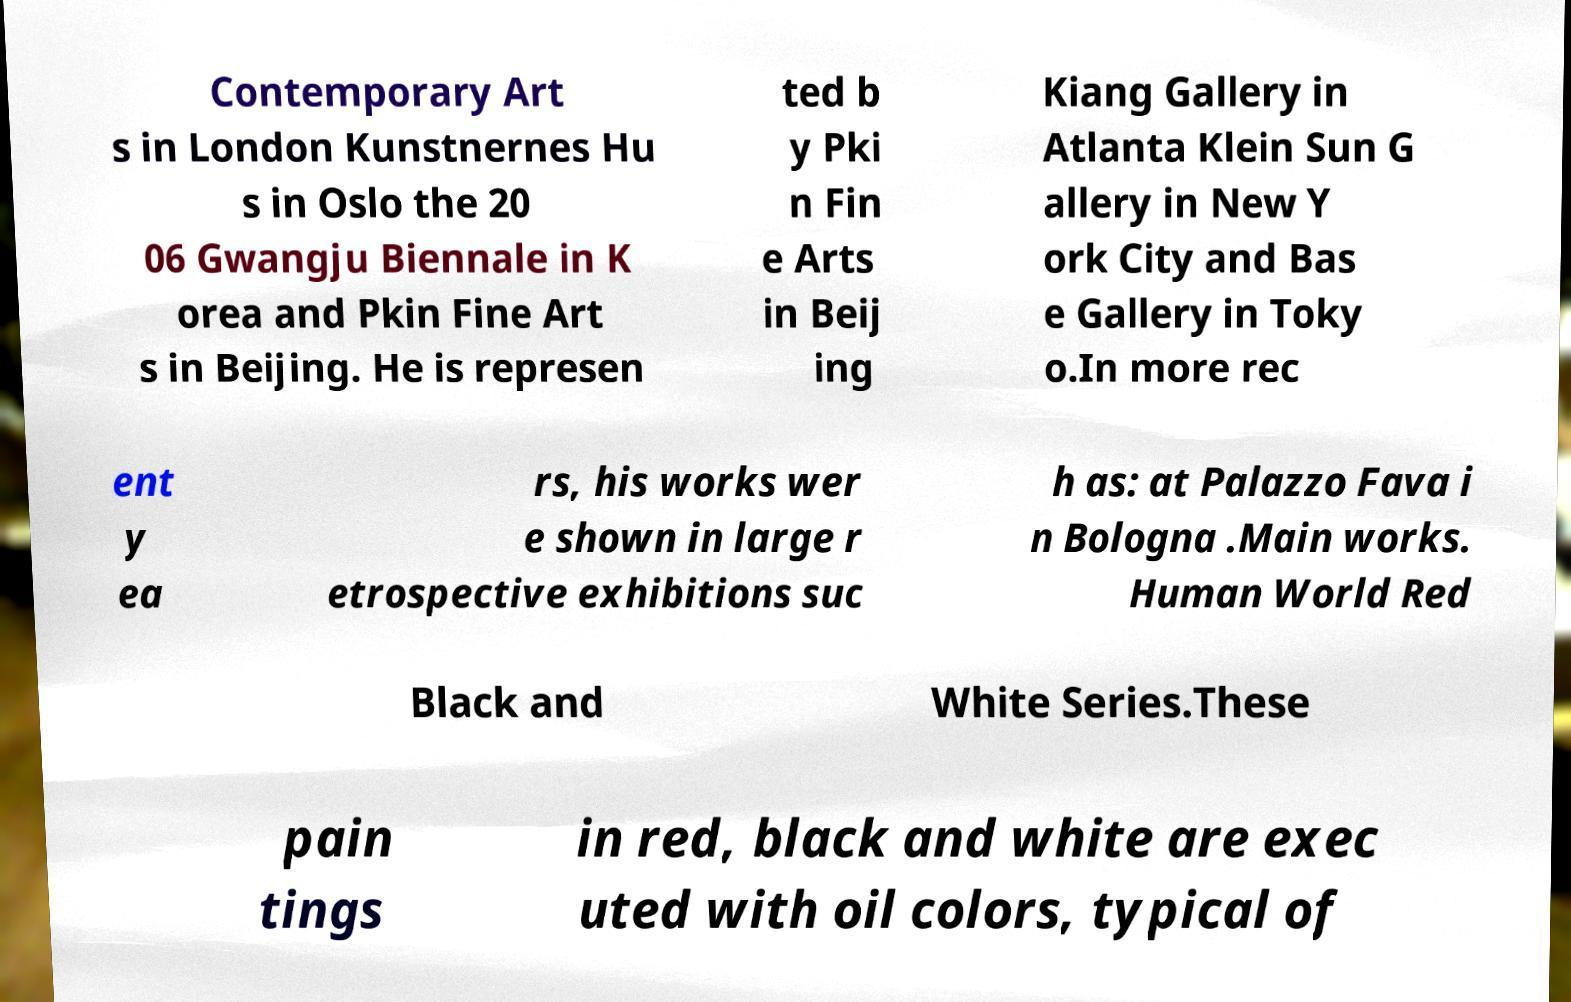What messages or text are displayed in this image? I need them in a readable, typed format. Contemporary Art s in London Kunstnernes Hu s in Oslo the 20 06 Gwangju Biennale in K orea and Pkin Fine Art s in Beijing. He is represen ted b y Pki n Fin e Arts in Beij ing Kiang Gallery in Atlanta Klein Sun G allery in New Y ork City and Bas e Gallery in Toky o.In more rec ent y ea rs, his works wer e shown in large r etrospective exhibitions suc h as: at Palazzo Fava i n Bologna .Main works. Human World Red Black and White Series.These pain tings in red, black and white are exec uted with oil colors, typical of 